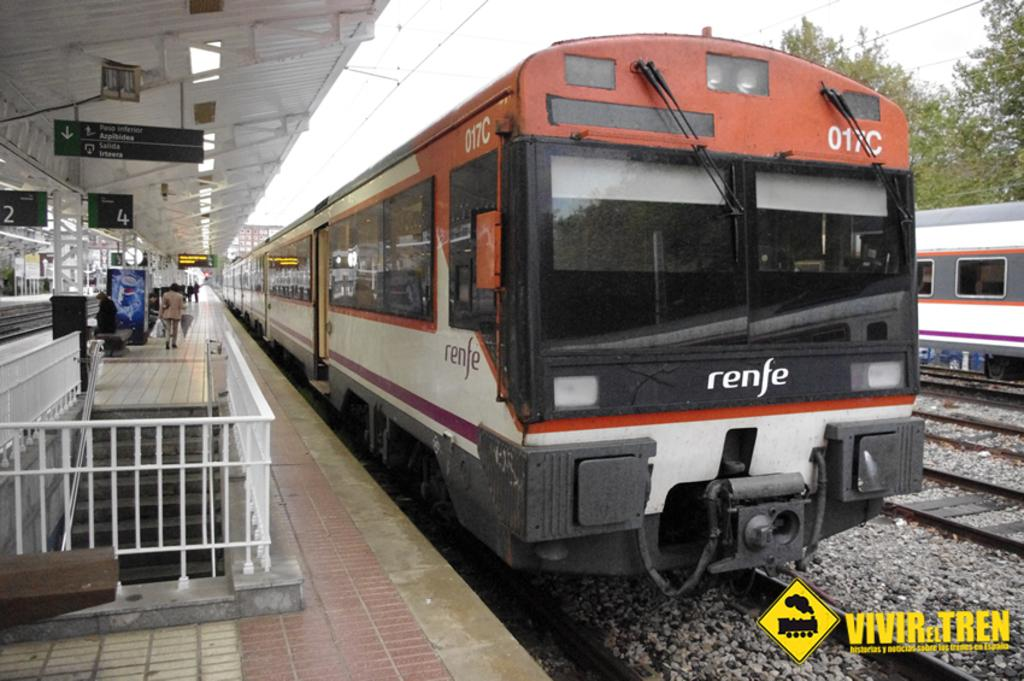<image>
Offer a succinct explanation of the picture presented. A Renfe train is marked as number 017C. 